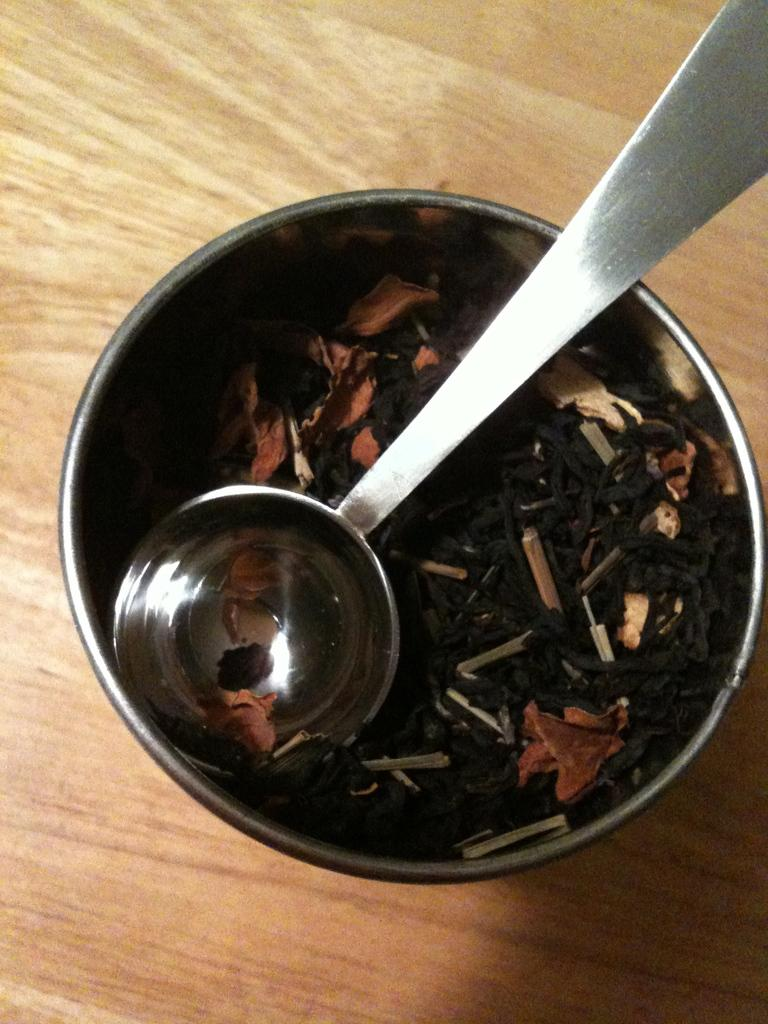What is located on the wooden surface in the image? There is a bowl on the wooden surface in the image. What is inside the bowl? There is a spoon in the bowl. Can you describe the material of the surface the bowl is placed on? The wooden surface is made of wood. What type of ear is visible in the image? There is no ear present in the image. 